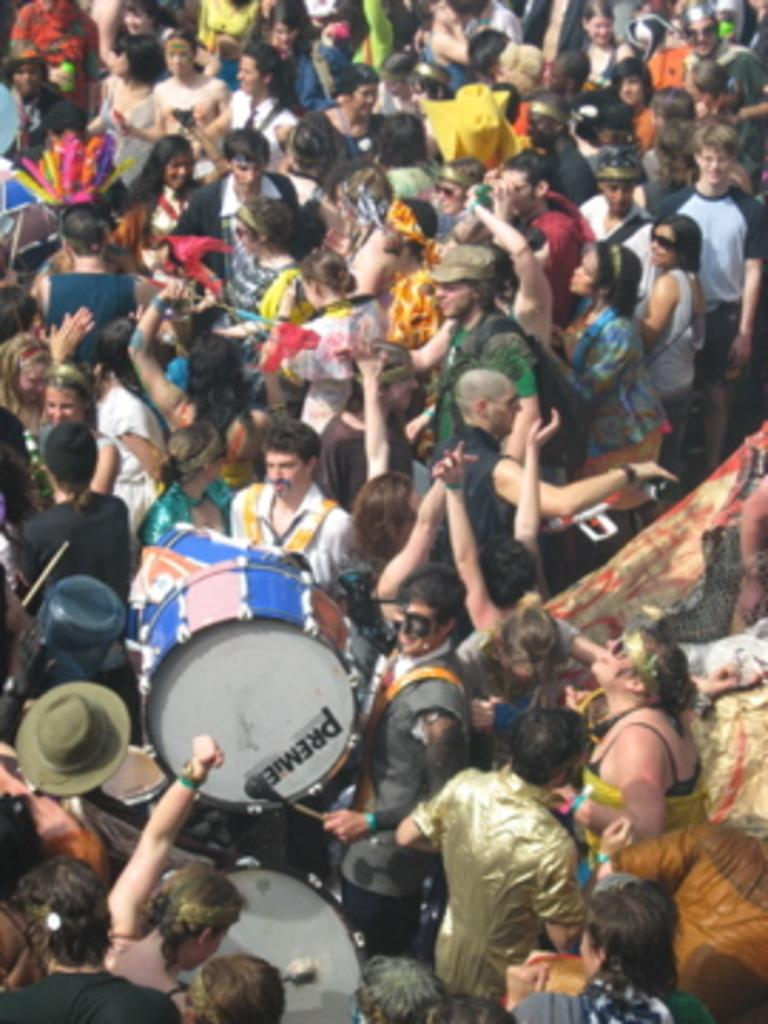How many people are in the image? There is a group of people in the image. What are some of the people in the group doing? Some people in the group are playing musical instruments. What type of gun can be seen in the hands of the people playing musical instruments? There is no gun present in the image; the people are playing musical instruments. 